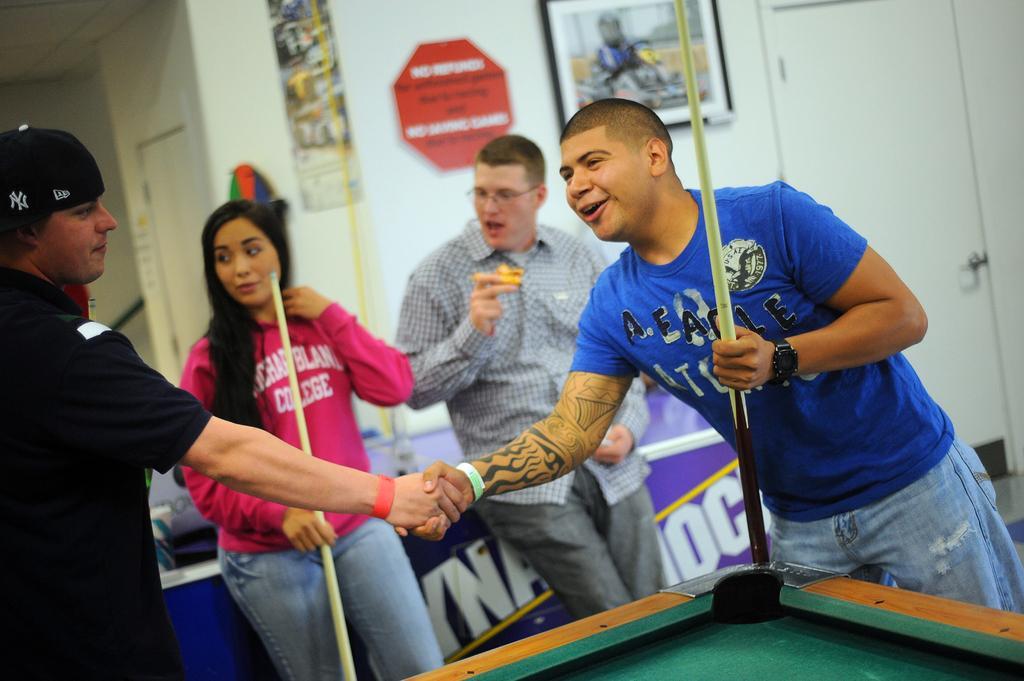Describe this image in one or two sentences. The picture is taken in a closed room where four people are present and at the right corner of the picture one man is wearing a blue t-shirt and jeans holding a stick in front of the table and behind them other person wearing shirt and holding something in his hand behind him there is a big wall with some photos on it and one door and another door and in the left corner of the picture one person is wearing black t-shirt and a cap, beside him there is a woman wearing pink t-shirt and blue jeans behind them there is another table. 